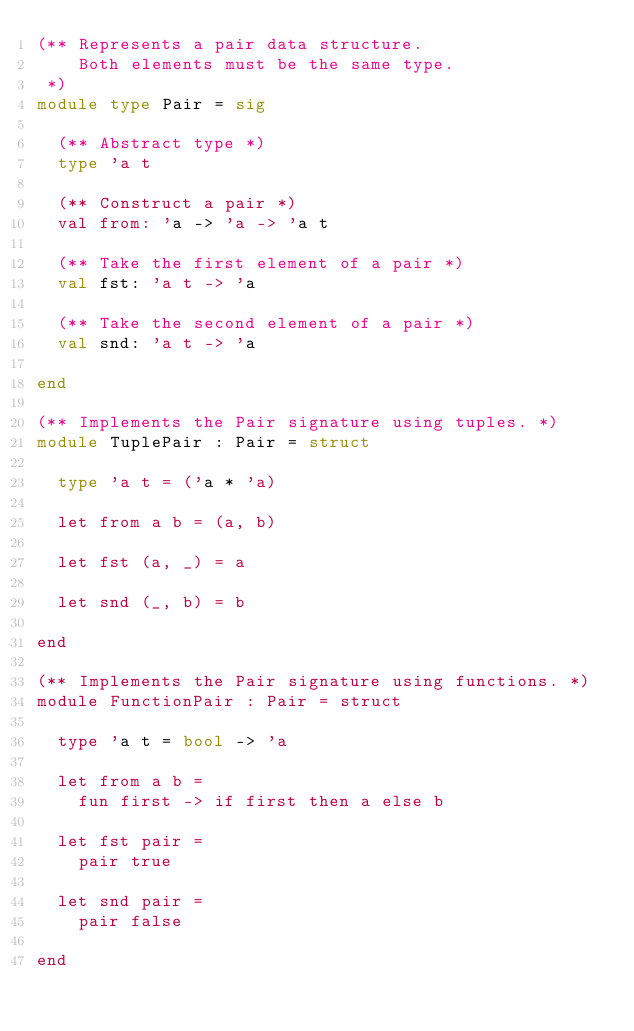<code> <loc_0><loc_0><loc_500><loc_500><_OCaml_>(** Represents a pair data structure.
    Both elements must be the same type.
 *)
module type Pair = sig

  (** Abstract type *)
  type 'a t

  (** Construct a pair *)
  val from: 'a -> 'a -> 'a t

  (** Take the first element of a pair *)
  val fst: 'a t -> 'a

  (** Take the second element of a pair *)
  val snd: 'a t -> 'a

end

(** Implements the Pair signature using tuples. *)
module TuplePair : Pair = struct

  type 'a t = ('a * 'a)

  let from a b = (a, b)

  let fst (a, _) = a

  let snd (_, b) = b

end

(** Implements the Pair signature using functions. *)
module FunctionPair : Pair = struct
  
  type 'a t = bool -> 'a

  let from a b =
    fun first -> if first then a else b

  let fst pair =
    pair true

  let snd pair =
    pair false

end
</code> 